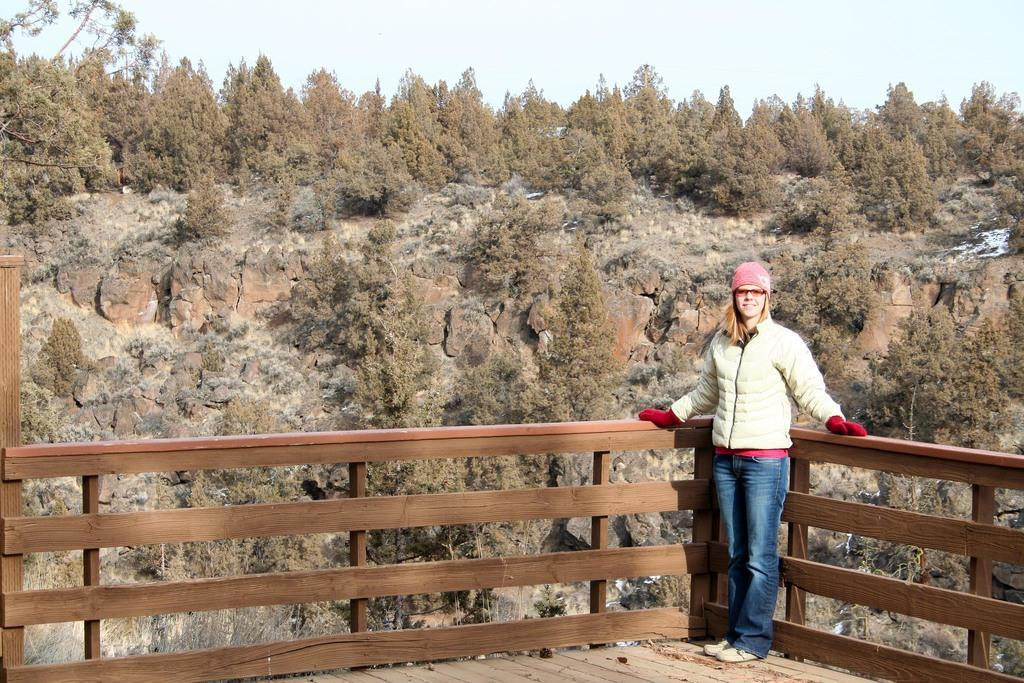What is the main subject in the image? There is a person standing in the image. What can be seen behind the person? There is a wooden fence in the image. What type of landscape feature is present in the image? There is a hill in the image. What type of vegetation is present in the image? There are trees in the image. What is visible in the background of the image? The sky is visible in the background of the image. What type of appliance is the person using to swim in the image? There is no appliance or swimming activity present in the image. 